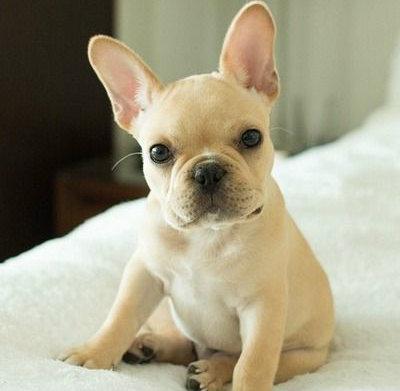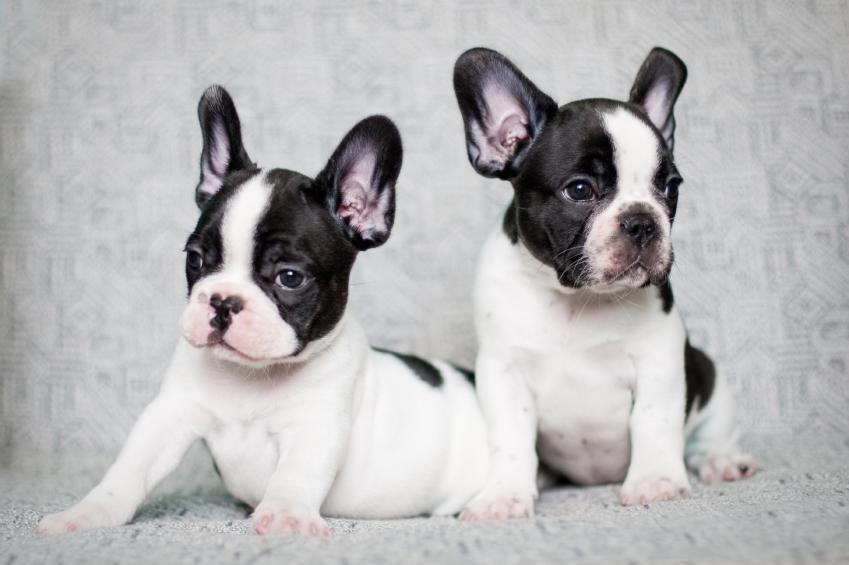The first image is the image on the left, the second image is the image on the right. Assess this claim about the two images: "An image shows a gray dog with a white mark on its chest.". Correct or not? Answer yes or no. No. 